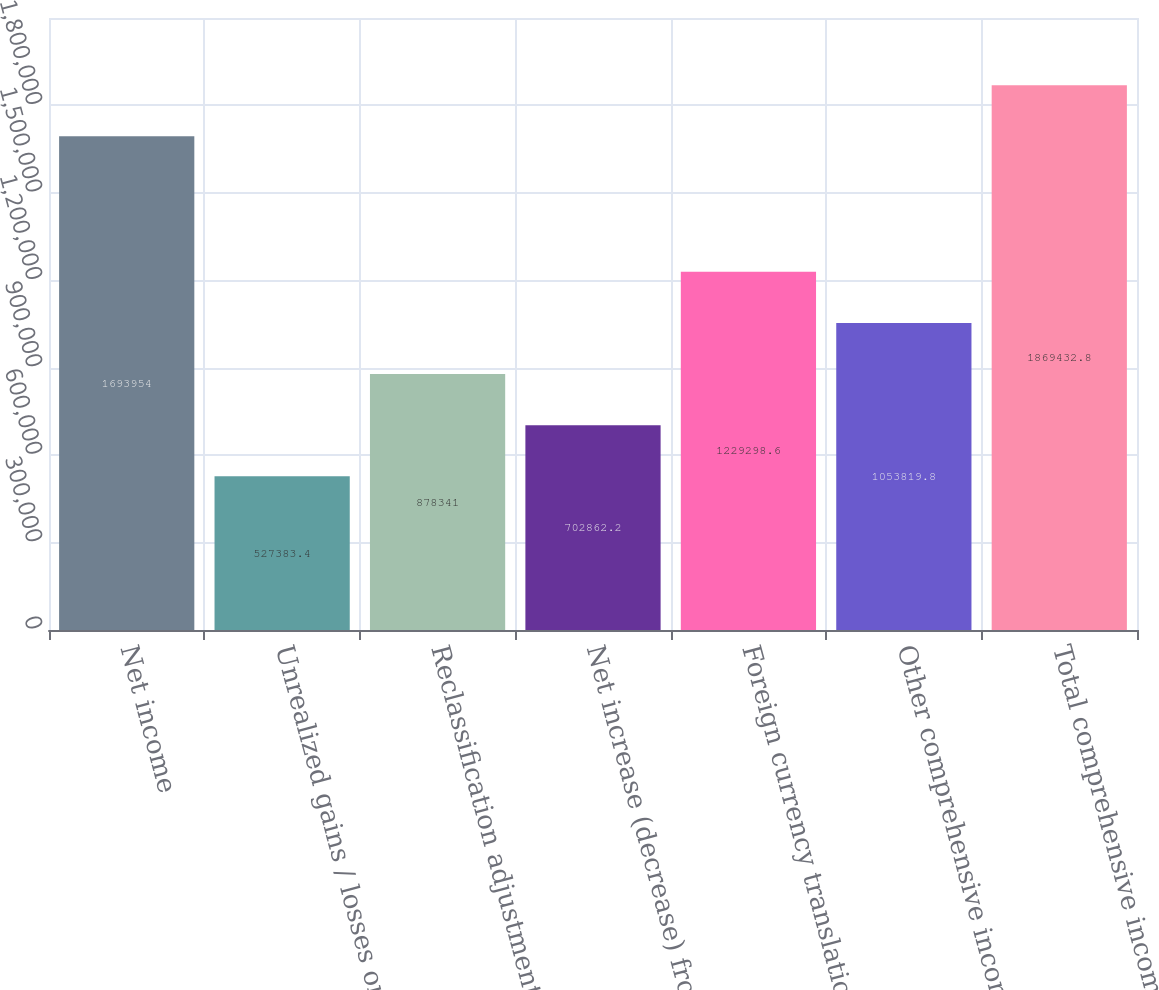Convert chart. <chart><loc_0><loc_0><loc_500><loc_500><bar_chart><fcel>Net income<fcel>Unrealized gains / losses on<fcel>Reclassification adjustment<fcel>Net increase (decrease) from<fcel>Foreign currency translation<fcel>Other comprehensive income<fcel>Total comprehensive income net<nl><fcel>1.69395e+06<fcel>527383<fcel>878341<fcel>702862<fcel>1.2293e+06<fcel>1.05382e+06<fcel>1.86943e+06<nl></chart> 